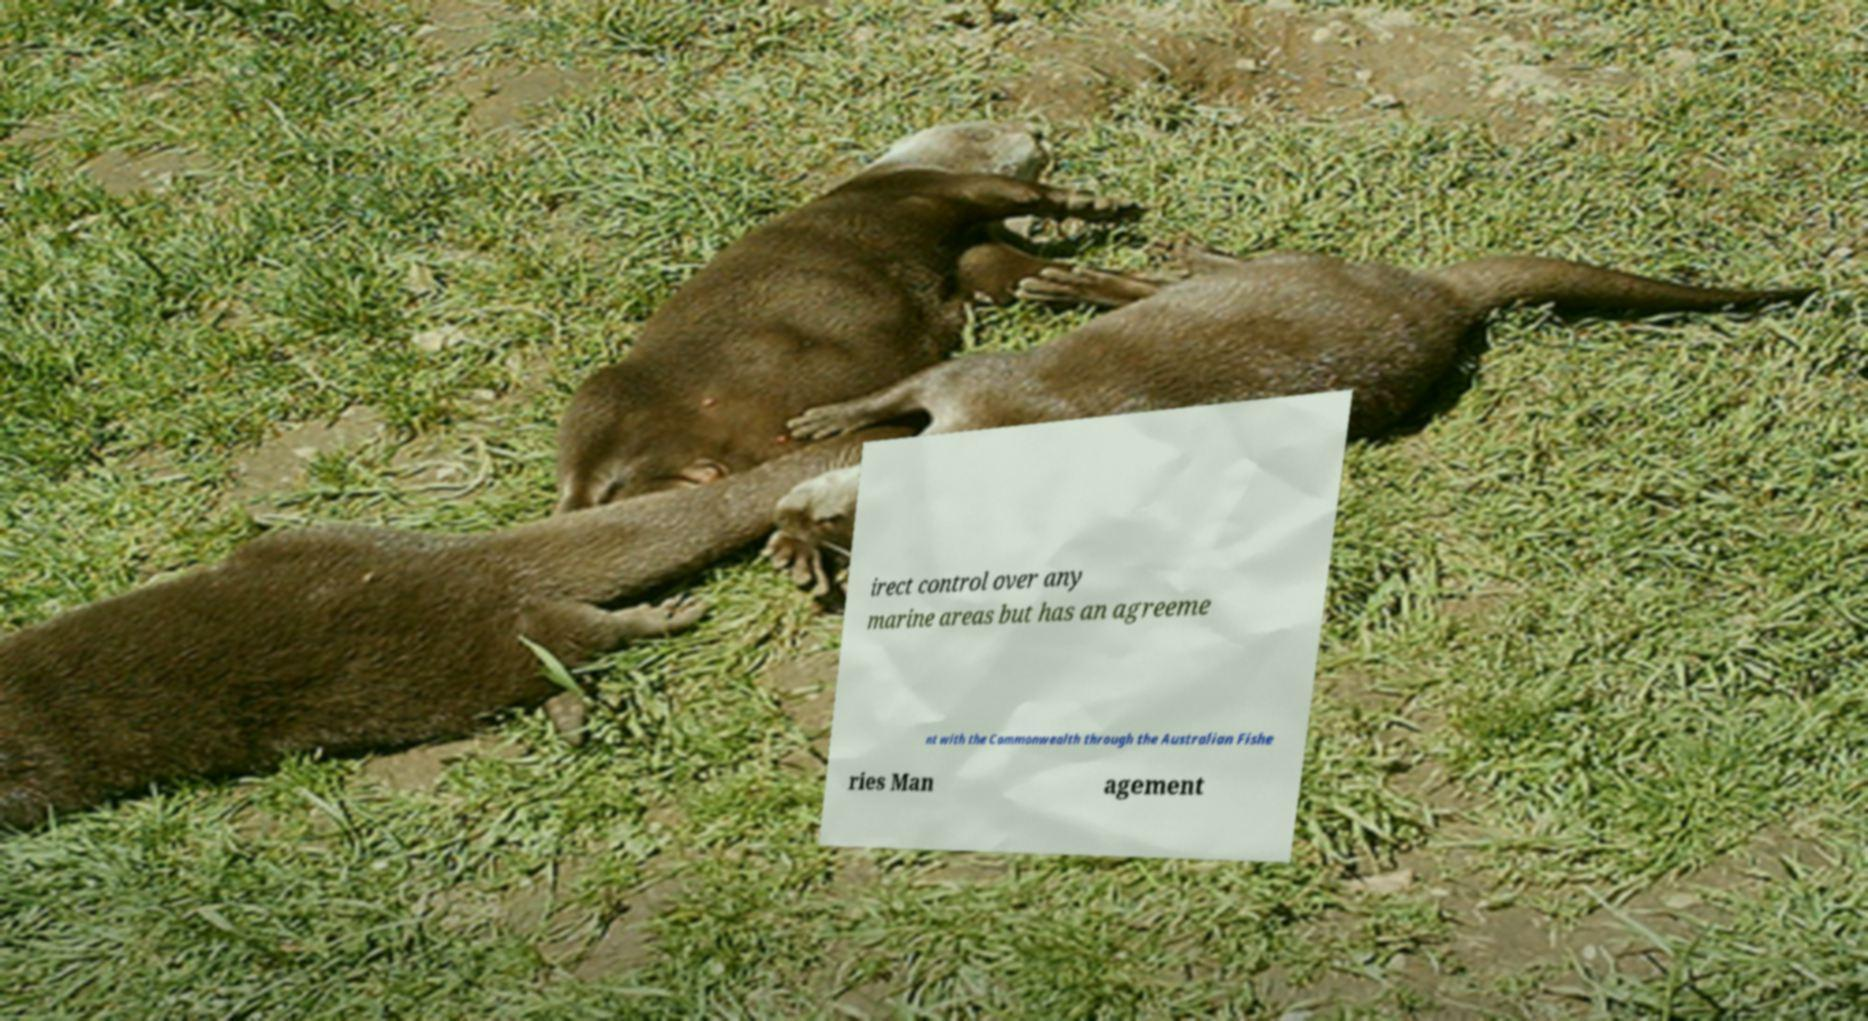Can you read and provide the text displayed in the image?This photo seems to have some interesting text. Can you extract and type it out for me? irect control over any marine areas but has an agreeme nt with the Commonwealth through the Australian Fishe ries Man agement 